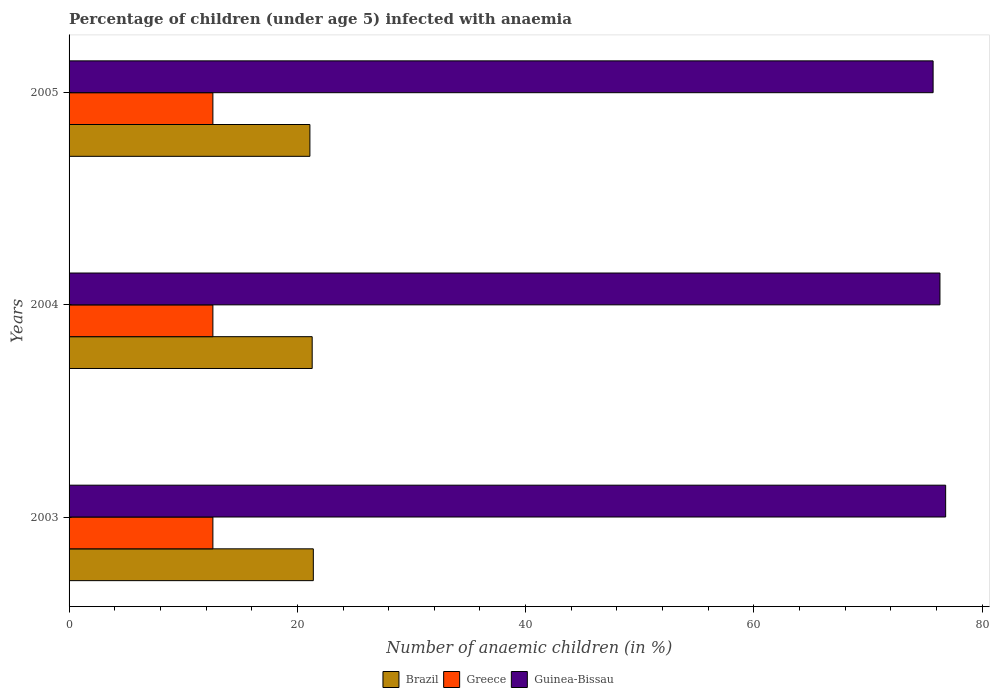Are the number of bars on each tick of the Y-axis equal?
Ensure brevity in your answer.  Yes. How many bars are there on the 1st tick from the bottom?
Your response must be concise. 3. What is the label of the 2nd group of bars from the top?
Ensure brevity in your answer.  2004. In how many cases, is the number of bars for a given year not equal to the number of legend labels?
Make the answer very short. 0. What is the percentage of children infected with anaemia in in Brazil in 2005?
Ensure brevity in your answer.  21.1. Across all years, what is the maximum percentage of children infected with anaemia in in Guinea-Bissau?
Provide a short and direct response. 76.8. Across all years, what is the minimum percentage of children infected with anaemia in in Guinea-Bissau?
Keep it short and to the point. 75.7. In which year was the percentage of children infected with anaemia in in Guinea-Bissau maximum?
Offer a very short reply. 2003. In which year was the percentage of children infected with anaemia in in Brazil minimum?
Ensure brevity in your answer.  2005. What is the total percentage of children infected with anaemia in in Greece in the graph?
Offer a terse response. 37.8. What is the difference between the percentage of children infected with anaemia in in Guinea-Bissau in 2004 and that in 2005?
Offer a very short reply. 0.6. What is the difference between the percentage of children infected with anaemia in in Greece in 2005 and the percentage of children infected with anaemia in in Brazil in 2003?
Offer a terse response. -8.8. In the year 2004, what is the difference between the percentage of children infected with anaemia in in Greece and percentage of children infected with anaemia in in Brazil?
Your answer should be very brief. -8.7. What is the ratio of the percentage of children infected with anaemia in in Guinea-Bissau in 2003 to that in 2005?
Offer a terse response. 1.01. What is the difference between the highest and the lowest percentage of children infected with anaemia in in Guinea-Bissau?
Give a very brief answer. 1.1. What does the 1st bar from the top in 2003 represents?
Your answer should be very brief. Guinea-Bissau. Is it the case that in every year, the sum of the percentage of children infected with anaemia in in Greece and percentage of children infected with anaemia in in Brazil is greater than the percentage of children infected with anaemia in in Guinea-Bissau?
Your response must be concise. No. How many legend labels are there?
Make the answer very short. 3. What is the title of the graph?
Offer a very short reply. Percentage of children (under age 5) infected with anaemia. Does "Latin America(developing only)" appear as one of the legend labels in the graph?
Your answer should be very brief. No. What is the label or title of the X-axis?
Offer a very short reply. Number of anaemic children (in %). What is the Number of anaemic children (in %) of Brazil in 2003?
Give a very brief answer. 21.4. What is the Number of anaemic children (in %) of Greece in 2003?
Provide a succinct answer. 12.6. What is the Number of anaemic children (in %) in Guinea-Bissau in 2003?
Your response must be concise. 76.8. What is the Number of anaemic children (in %) of Brazil in 2004?
Make the answer very short. 21.3. What is the Number of anaemic children (in %) in Guinea-Bissau in 2004?
Ensure brevity in your answer.  76.3. What is the Number of anaemic children (in %) in Brazil in 2005?
Make the answer very short. 21.1. What is the Number of anaemic children (in %) of Guinea-Bissau in 2005?
Give a very brief answer. 75.7. Across all years, what is the maximum Number of anaemic children (in %) of Brazil?
Provide a succinct answer. 21.4. Across all years, what is the maximum Number of anaemic children (in %) in Guinea-Bissau?
Give a very brief answer. 76.8. Across all years, what is the minimum Number of anaemic children (in %) in Brazil?
Ensure brevity in your answer.  21.1. Across all years, what is the minimum Number of anaemic children (in %) in Greece?
Give a very brief answer. 12.6. Across all years, what is the minimum Number of anaemic children (in %) of Guinea-Bissau?
Ensure brevity in your answer.  75.7. What is the total Number of anaemic children (in %) of Brazil in the graph?
Keep it short and to the point. 63.8. What is the total Number of anaemic children (in %) in Greece in the graph?
Your answer should be compact. 37.8. What is the total Number of anaemic children (in %) in Guinea-Bissau in the graph?
Your response must be concise. 228.8. What is the difference between the Number of anaemic children (in %) of Brazil in 2004 and that in 2005?
Give a very brief answer. 0.2. What is the difference between the Number of anaemic children (in %) in Greece in 2004 and that in 2005?
Make the answer very short. 0. What is the difference between the Number of anaemic children (in %) in Guinea-Bissau in 2004 and that in 2005?
Offer a very short reply. 0.6. What is the difference between the Number of anaemic children (in %) in Brazil in 2003 and the Number of anaemic children (in %) in Guinea-Bissau in 2004?
Your response must be concise. -54.9. What is the difference between the Number of anaemic children (in %) in Greece in 2003 and the Number of anaemic children (in %) in Guinea-Bissau in 2004?
Make the answer very short. -63.7. What is the difference between the Number of anaemic children (in %) in Brazil in 2003 and the Number of anaemic children (in %) in Greece in 2005?
Give a very brief answer. 8.8. What is the difference between the Number of anaemic children (in %) of Brazil in 2003 and the Number of anaemic children (in %) of Guinea-Bissau in 2005?
Offer a very short reply. -54.3. What is the difference between the Number of anaemic children (in %) of Greece in 2003 and the Number of anaemic children (in %) of Guinea-Bissau in 2005?
Give a very brief answer. -63.1. What is the difference between the Number of anaemic children (in %) in Brazil in 2004 and the Number of anaemic children (in %) in Greece in 2005?
Provide a short and direct response. 8.7. What is the difference between the Number of anaemic children (in %) of Brazil in 2004 and the Number of anaemic children (in %) of Guinea-Bissau in 2005?
Offer a terse response. -54.4. What is the difference between the Number of anaemic children (in %) of Greece in 2004 and the Number of anaemic children (in %) of Guinea-Bissau in 2005?
Provide a succinct answer. -63.1. What is the average Number of anaemic children (in %) of Brazil per year?
Keep it short and to the point. 21.27. What is the average Number of anaemic children (in %) of Guinea-Bissau per year?
Give a very brief answer. 76.27. In the year 2003, what is the difference between the Number of anaemic children (in %) in Brazil and Number of anaemic children (in %) in Greece?
Your response must be concise. 8.8. In the year 2003, what is the difference between the Number of anaemic children (in %) in Brazil and Number of anaemic children (in %) in Guinea-Bissau?
Ensure brevity in your answer.  -55.4. In the year 2003, what is the difference between the Number of anaemic children (in %) of Greece and Number of anaemic children (in %) of Guinea-Bissau?
Ensure brevity in your answer.  -64.2. In the year 2004, what is the difference between the Number of anaemic children (in %) of Brazil and Number of anaemic children (in %) of Greece?
Give a very brief answer. 8.7. In the year 2004, what is the difference between the Number of anaemic children (in %) of Brazil and Number of anaemic children (in %) of Guinea-Bissau?
Your response must be concise. -55. In the year 2004, what is the difference between the Number of anaemic children (in %) in Greece and Number of anaemic children (in %) in Guinea-Bissau?
Your answer should be very brief. -63.7. In the year 2005, what is the difference between the Number of anaemic children (in %) in Brazil and Number of anaemic children (in %) in Greece?
Provide a short and direct response. 8.5. In the year 2005, what is the difference between the Number of anaemic children (in %) of Brazil and Number of anaemic children (in %) of Guinea-Bissau?
Your response must be concise. -54.6. In the year 2005, what is the difference between the Number of anaemic children (in %) of Greece and Number of anaemic children (in %) of Guinea-Bissau?
Your answer should be very brief. -63.1. What is the ratio of the Number of anaemic children (in %) in Brazil in 2003 to that in 2004?
Keep it short and to the point. 1. What is the ratio of the Number of anaemic children (in %) of Guinea-Bissau in 2003 to that in 2004?
Offer a very short reply. 1.01. What is the ratio of the Number of anaemic children (in %) in Brazil in 2003 to that in 2005?
Provide a succinct answer. 1.01. What is the ratio of the Number of anaemic children (in %) in Guinea-Bissau in 2003 to that in 2005?
Ensure brevity in your answer.  1.01. What is the ratio of the Number of anaemic children (in %) in Brazil in 2004 to that in 2005?
Your response must be concise. 1.01. What is the ratio of the Number of anaemic children (in %) of Greece in 2004 to that in 2005?
Ensure brevity in your answer.  1. What is the ratio of the Number of anaemic children (in %) in Guinea-Bissau in 2004 to that in 2005?
Your response must be concise. 1.01. What is the difference between the highest and the lowest Number of anaemic children (in %) of Brazil?
Offer a terse response. 0.3. What is the difference between the highest and the lowest Number of anaemic children (in %) of Greece?
Offer a terse response. 0. 